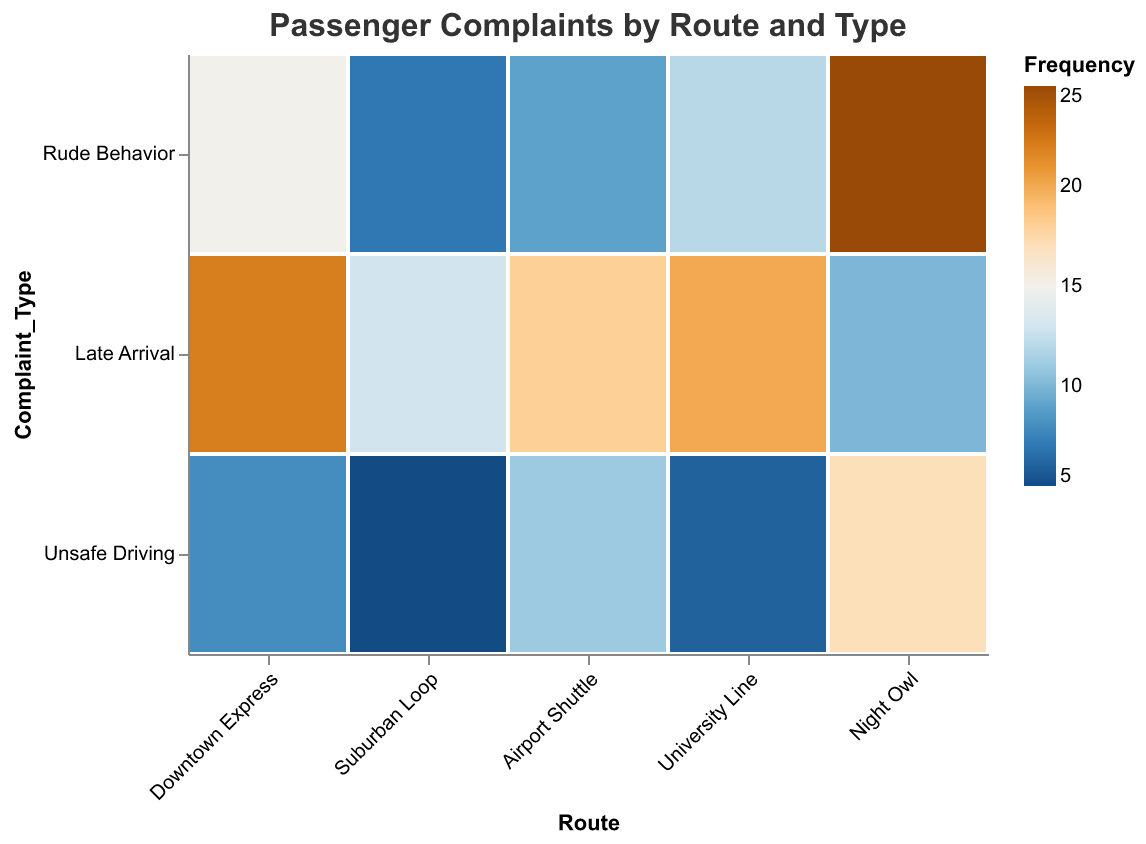How many routes are depicted in the plot? The plot contains five different routes: "Downtown Express," "Suburban Loop," "Airport Shuttle," "University Line," and "Night Owl." Simply count the distinct routes displayed in the x-axis.
Answer: 5 Which complaint type has the highest frequency for the Airport Shuttle route? Look for the "Airport Shuttle" category on the x-axis, then within that vertical section, identify which complaint type has the highest value on the color scale. In this case, "Late Arrival" has the highest frequency (18).
Answer: Late Arrival What is the total number of complaints for the University Line route? Sum the frequencies of all complaint types related to the "University Line": 12 (Rude Behavior) + 20 (Late Arrival) + 6 (Unsafe Driving).
Answer: 38 Which route has the highest total number of complaints? To find the route with the highest total complaints, sum the frequencies for each route and compare: 
- Downtown Express: 15 + 22 + 8 = 45
- Suburban Loop: 7 + 13 + 5 = 25
- Airport Shuttle: 9 + 18 + 11 = 38
- University Line: 12 + 20 + 6 = 38
- Night Owl: 25 + 10 + 17 = 52
Night Owl has the highest total.
Answer: Night Owl Which complaint type has the least frequency in Rude Behavior complaints across all routes? Identify and compare the frequencies of "Rude Behavior" complaints across all routes. 
- Downtown Express: 15
- Suburban Loop: 7
- Airport Shuttle: 9
- University Line: 12
- Night Owl: 25
The least frequency is 7 for Suburban Loop.
Answer: Suburban Loop How does the frequency of Unsafe Driving complaints for the Night Owl compare to that for the Downtown Express? Compare the frequencies: Night Owl has 17, while Downtown Express has 8. Hence, Night Owl has more Unsafe Driving complaints than Downtown Express.
Answer: Night Owl has more What is the average frequency of Late Arrival complaints across all routes? The frequencies are 22 (Downtown Express) + 13 (Suburban Loop) + 18 (Airport Shuttle) + 20 (University Line) + 10 (Night Owl). The sum is 83; there are 5 routes. Therefore, 83 / 5 = 16.6.
Answer: 16.6 Which route has the most varied types of complaints, in terms of frequency spread? Assess the variability by evaluating the spread of the frequency within each route:
- Downtown Express (15, 22, 8; spread ±7 and ±14)
- Suburban Loop (7, 13, 5; spread ±2 and ±6)
- Airport Shuttle (9, 18, 11; spread ±2 and ±9)
- University Line (12, 20, 6; spread ±6 and ±14)
- Night Owl (25, 10, 17; spread ±8 and ±15)
Overall, Night Owl displays the most varied spread.
Answer: Night Owl 